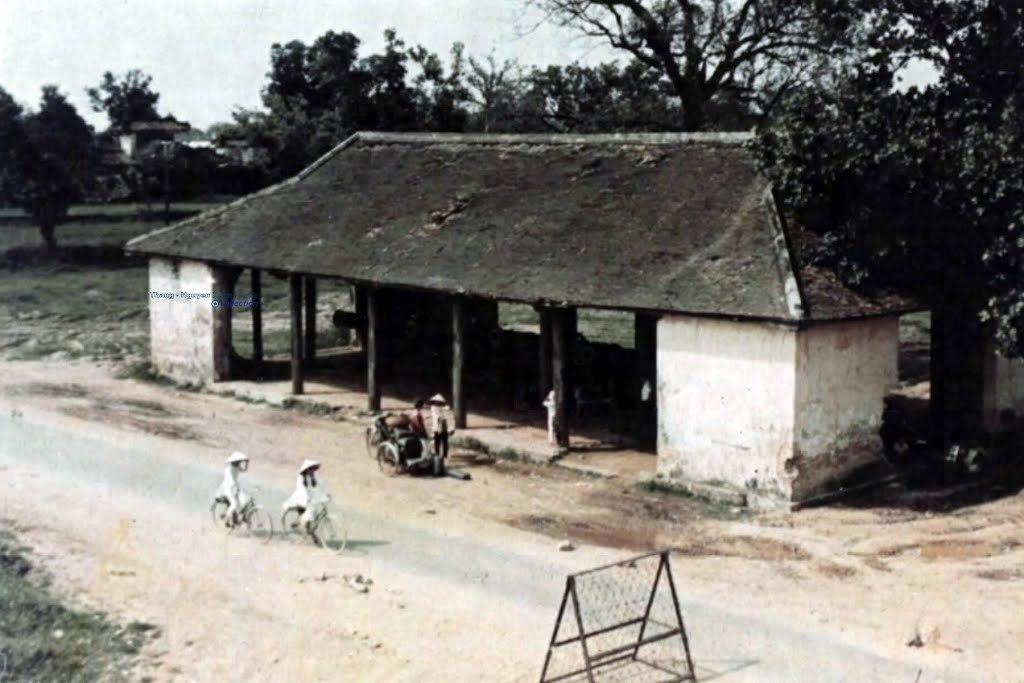What type of outdoor space is depicted in the image? The image shows a rooftop. What structures can be seen on the rooftop? There is a wall and a building visible in the image. What type of transportation is present on the rooftop? There are bicycles in the image. What type of vegetation is present on the rooftop? There is grass and trees in the image. What is visible at the top of the image? The sky is visible at the top of the image. What type of plantation is visible in the image? There is no plantation present in the image; it shows a rooftop with various structures and objects. What type of office can be seen in the image? There is no office present in the image; it shows a rooftop with various structures and objects. 